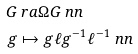<formula> <loc_0><loc_0><loc_500><loc_500>G & \ r a \Omega G \ n n \\ g & \mapsto g \ell g ^ { - 1 } \ell ^ { - 1 } \ n n</formula> 